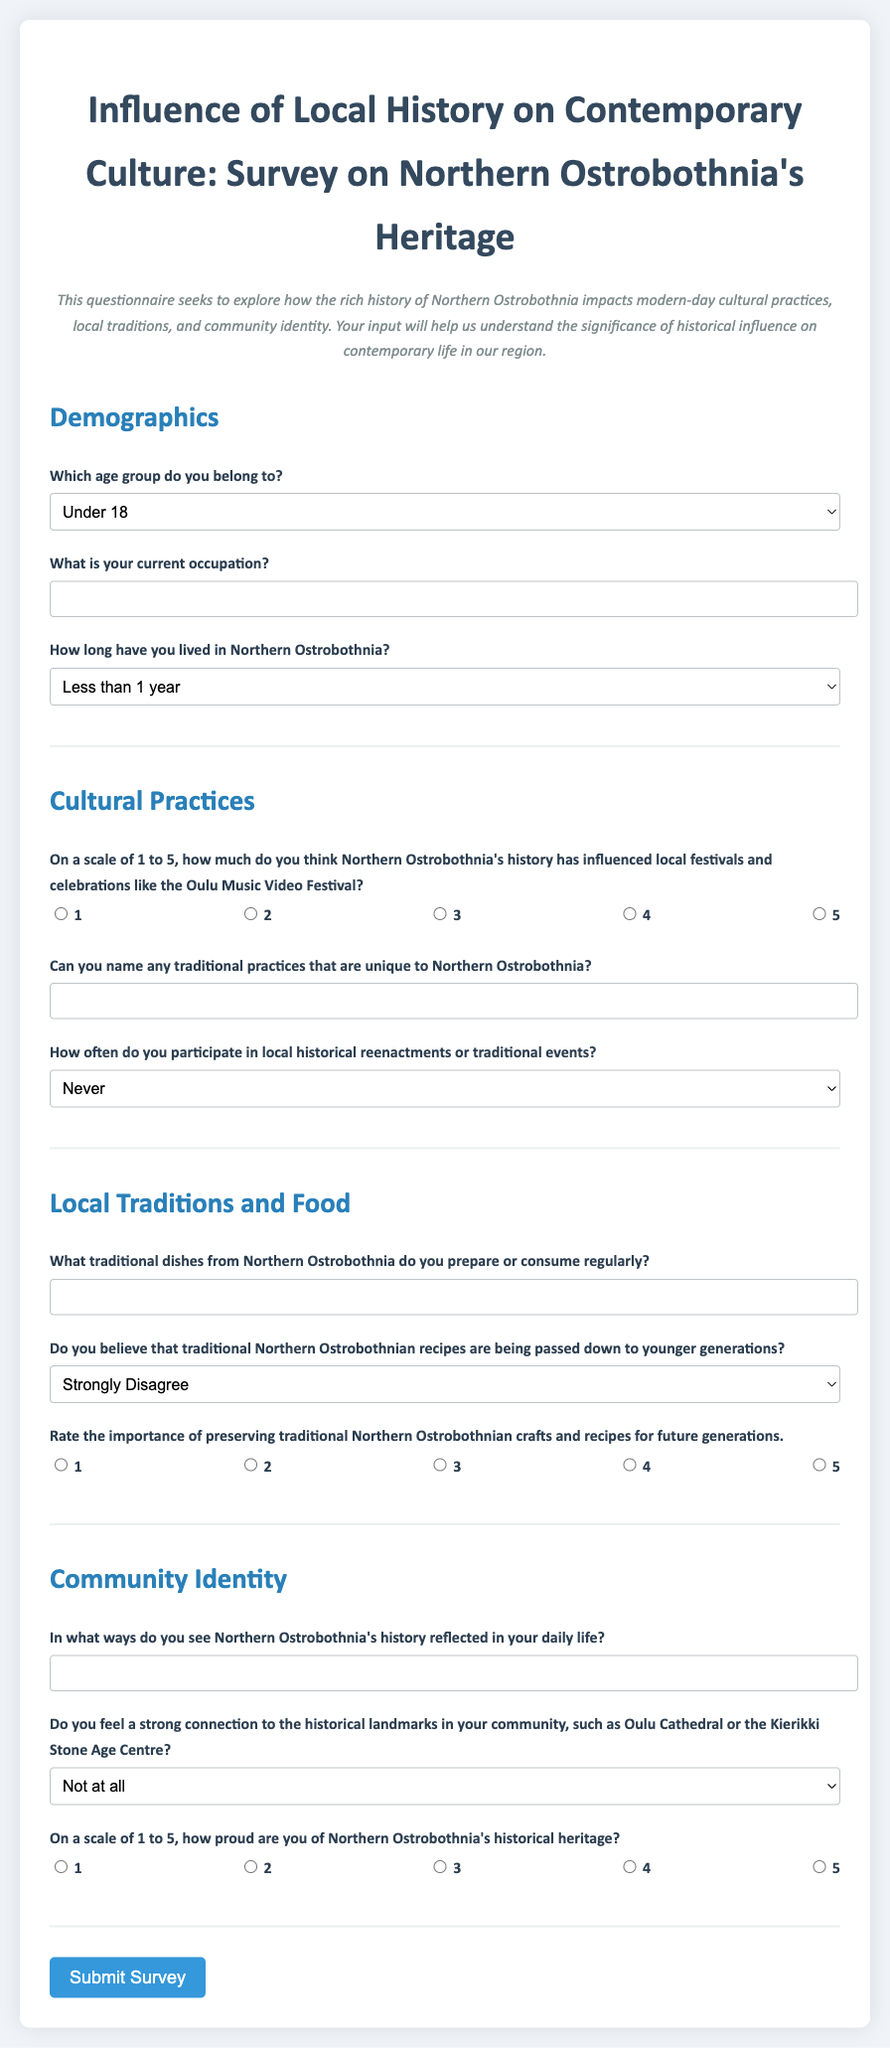What is the title of the survey? The title of the survey is indicated at the top of the document.
Answer: Influence of Local History on Contemporary Culture: Survey on Northern Ostrobothnia's Heritage How many sections are included in the survey? The survey consists of four sections as listed in the document: Demographics, Cultural Practices, Local Traditions and Food, Community Identity.
Answer: Four What is one of the traditional dishes that respondents are asked about? The document asks respondents to name traditional dishes unique to Northern Ostrobothnia, referring to regional cuisine.
Answer: Traditional dishes What is the highest rating scale used in the survey for pride in heritage? Respondents rate their pride on a scale of 1 to 5, with 5 being the highest.
Answer: 5 What occupation-related question is asked in the demographics section? The document includes a question asking about the respondent's current occupation.
Answer: What is your current occupation? How long do respondents have to live in Northern Ostrobothnia to select 'I have lived here my whole life'? There is an option that reflects lifelong residency in the area.
Answer: I have lived here my whole life What is one of the options for how often people participate in local historical events? Respondents can choose 'Rarely' as a frequency option for their participation.
Answer: Rarely What type of connection does the survey inquire about in relation to local historical landmarks? The survey asks about the strength of connection to historical landmarks in the community, such as Oulu Cathedral.
Answer: Strong connection What is the purpose of this questionnaire? The purpose is outlined in the introductory paragraph of the document to explore cultural and historical influences.
Answer: To explore historical influence on contemporary life in Northern Ostrobothnia 